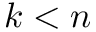<formula> <loc_0><loc_0><loc_500><loc_500>k < n</formula> 